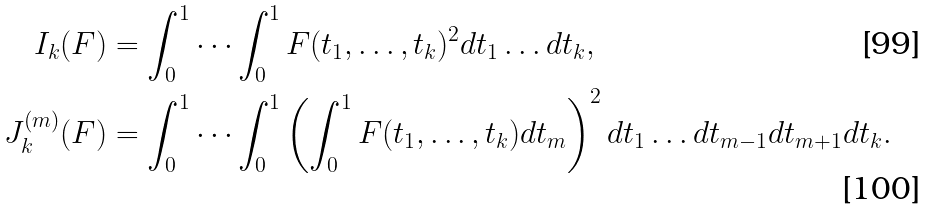<formula> <loc_0><loc_0><loc_500><loc_500>I _ { k } ( F ) & = \int _ { 0 } ^ { 1 } \cdots \int _ { 0 } ^ { 1 } F ( t _ { 1 } , \dots , t _ { k } ) ^ { 2 } d t _ { 1 } \dots d t _ { k } , \\ J _ { k } ^ { ( m ) } ( F ) & = \int _ { 0 } ^ { 1 } \cdots \int _ { 0 } ^ { 1 } \left ( \int _ { 0 } ^ { 1 } F ( t _ { 1 } , \dots , t _ { k } ) d t _ { m } \right ) ^ { 2 } d t _ { 1 } \dots d t _ { m - 1 } d t _ { m + 1 } d t _ { k } .</formula> 